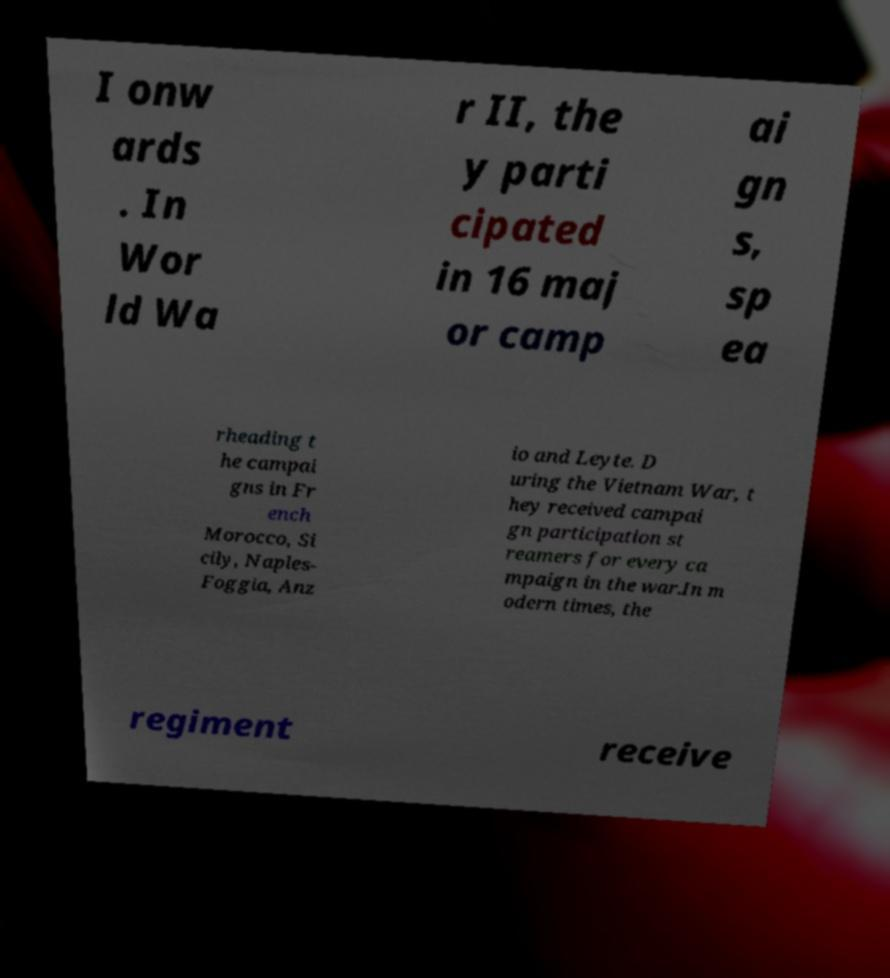Can you accurately transcribe the text from the provided image for me? I onw ards . In Wor ld Wa r II, the y parti cipated in 16 maj or camp ai gn s, sp ea rheading t he campai gns in Fr ench Morocco, Si cily, Naples- Foggia, Anz io and Leyte. D uring the Vietnam War, t hey received campai gn participation st reamers for every ca mpaign in the war.In m odern times, the regiment receive 